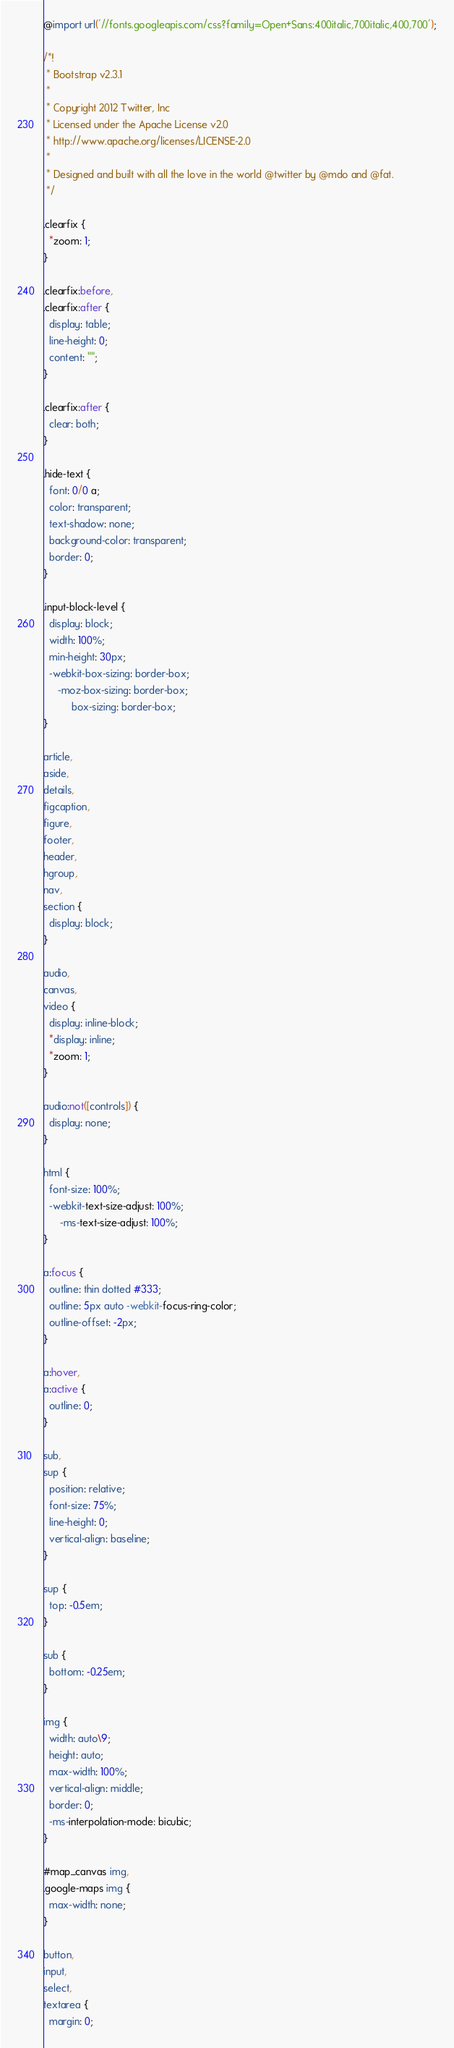Convert code to text. <code><loc_0><loc_0><loc_500><loc_500><_CSS_>@import url('//fonts.googleapis.com/css?family=Open+Sans:400italic,700italic,400,700');

/*!
 * Bootstrap v2.3.1
 *
 * Copyright 2012 Twitter, Inc
 * Licensed under the Apache License v2.0
 * http://www.apache.org/licenses/LICENSE-2.0
 *
 * Designed and built with all the love in the world @twitter by @mdo and @fat.
 */

.clearfix {
  *zoom: 1;
}

.clearfix:before,
.clearfix:after {
  display: table;
  line-height: 0;
  content: "";
}

.clearfix:after {
  clear: both;
}

.hide-text {
  font: 0/0 a;
  color: transparent;
  text-shadow: none;
  background-color: transparent;
  border: 0;
}

.input-block-level {
  display: block;
  width: 100%;
  min-height: 30px;
  -webkit-box-sizing: border-box;
     -moz-box-sizing: border-box;
          box-sizing: border-box;
}

article,
aside,
details,
figcaption,
figure,
footer,
header,
hgroup,
nav,
section {
  display: block;
}

audio,
canvas,
video {
  display: inline-block;
  *display: inline;
  *zoom: 1;
}

audio:not([controls]) {
  display: none;
}

html {
  font-size: 100%;
  -webkit-text-size-adjust: 100%;
      -ms-text-size-adjust: 100%;
}

a:focus {
  outline: thin dotted #333;
  outline: 5px auto -webkit-focus-ring-color;
  outline-offset: -2px;
}

a:hover,
a:active {
  outline: 0;
}

sub,
sup {
  position: relative;
  font-size: 75%;
  line-height: 0;
  vertical-align: baseline;
}

sup {
  top: -0.5em;
}

sub {
  bottom: -0.25em;
}

img {
  width: auto\9;
  height: auto;
  max-width: 100%;
  vertical-align: middle;
  border: 0;
  -ms-interpolation-mode: bicubic;
}

#map_canvas img,
.google-maps img {
  max-width: none;
}

button,
input,
select,
textarea {
  margin: 0;</code> 